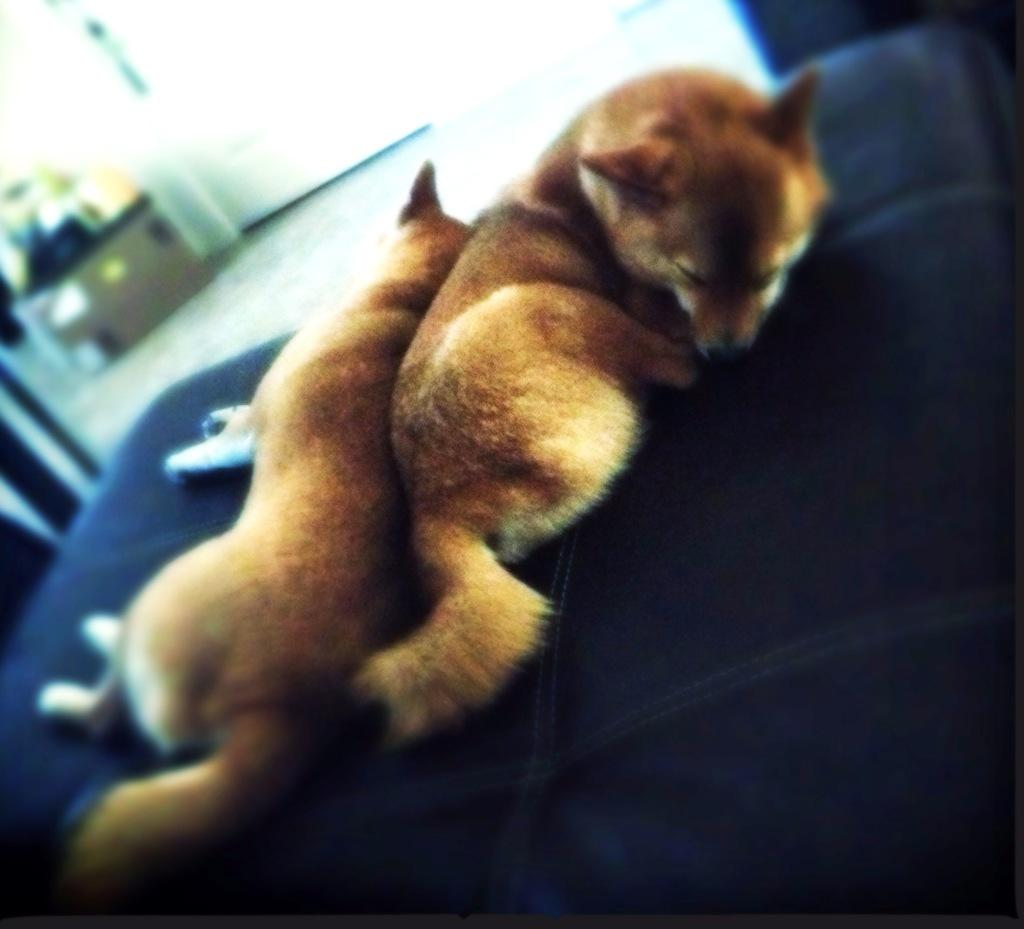How many dogs are depicted in the image? There are two dogs in the image. What are the dogs doing in the image? The dogs are sleeping. Where are the dogs located in the image? The dogs are on a bed. What is the color of the bed in the image? The bed is blue in color. How does the pollution affect the flight of the toad in the image? There is no toad or flight present in the image, and therefore no such effect can be observed. 